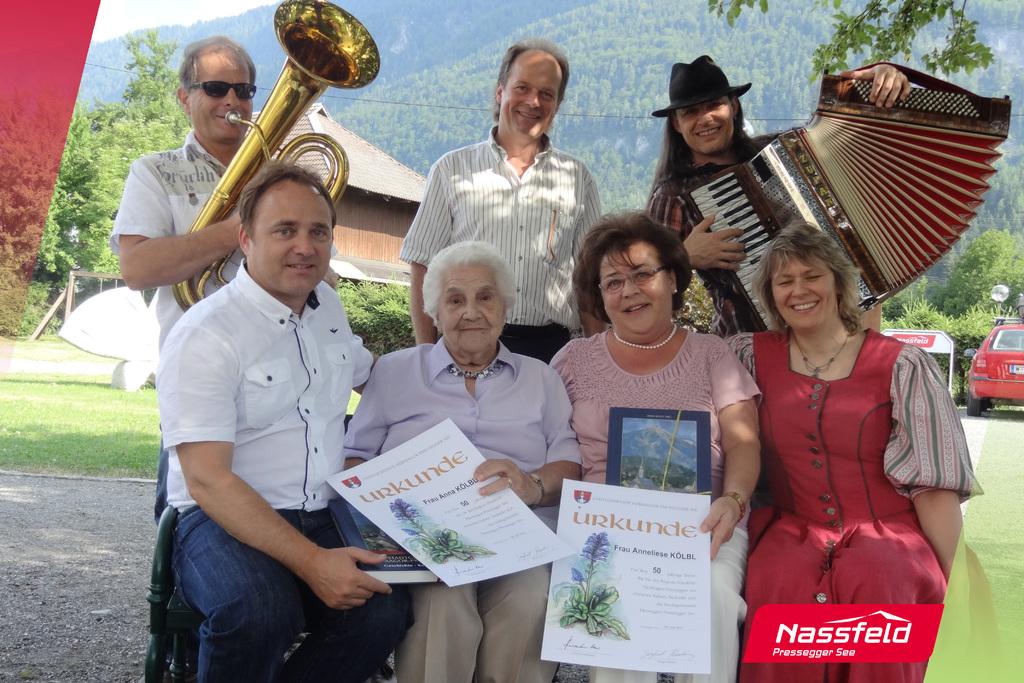What company is shown in the red logo?
Make the answer very short. Nassfeld. What is the publication name?
Provide a succinct answer. Urkunde. 